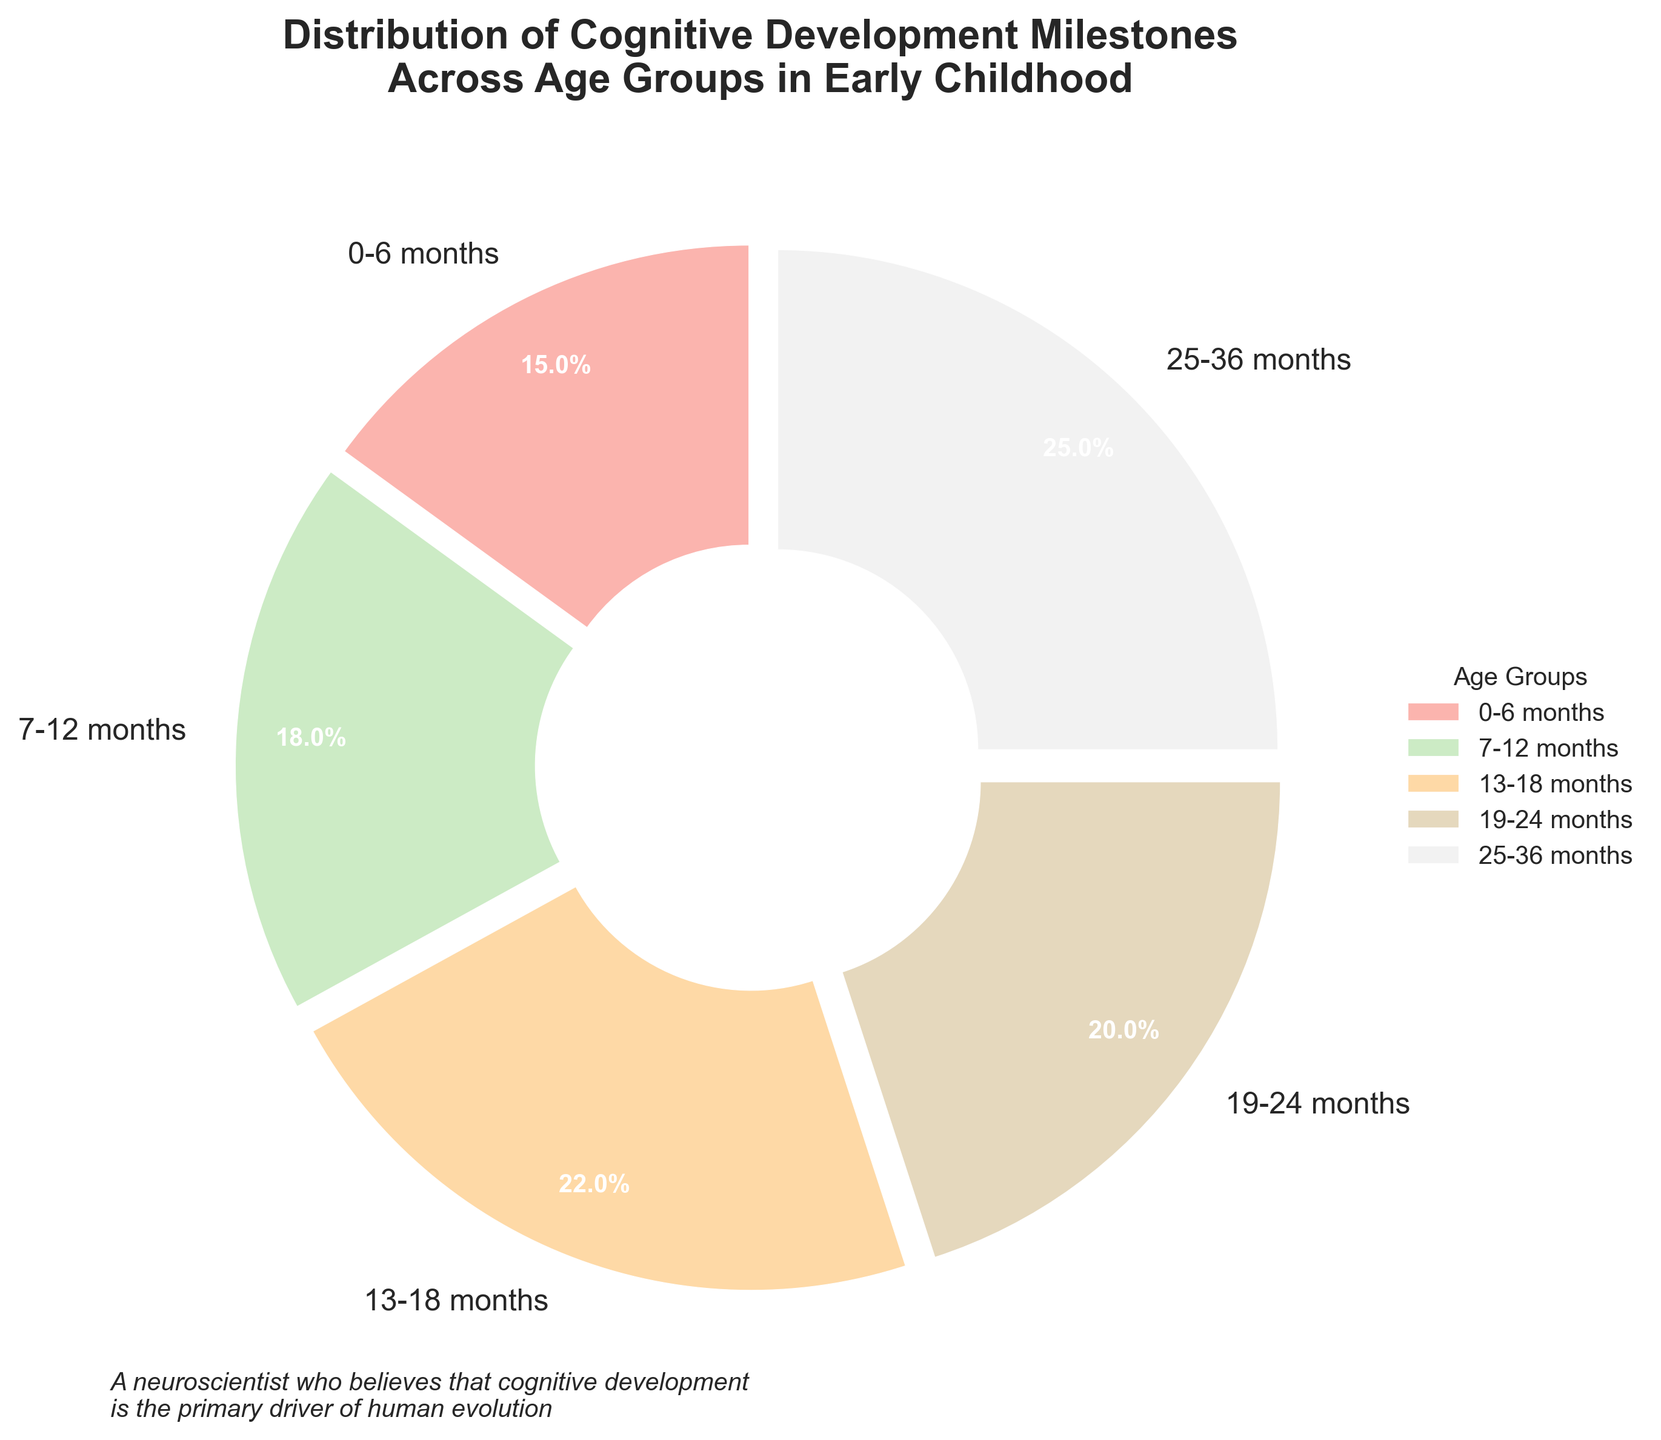What age group has the highest percentage of cognitive development milestones? By looking at the pie chart, the segment corresponding to the age group 25-36 months is the largest, representing the highest percentage of cognitive development milestones.
Answer: 25-36 months Which age group has a lower percentage of cognitive development milestones: 0-6 months or 7-12 months? Comparing the pie chart segments for the age groups 0-6 months and 7-12 months, the 0-6 months segment is smaller, indicating a lower percentage.
Answer: 0-6 months What is the combined percentage of cognitive milestones for the age groups 13-18 months and 19-24 months? The pie chart shows 22% for the 13-18 months age group and 20% for the 19-24 months age group. Adding these percentages gives 22 + 20 = 42%.
Answer: 42% How much larger is the percentage of the 25-36 months age group compared to the 0-6 months age group? The pie chart shows 25% for 25-36 months and 15% for 0-6 months. The difference between them is 25 - 15 = 10%.
Answer: 10% Which two age groups have the most similar percentages of cognitive development milestones? By visually comparing the segments on the pie chart, the age groups 19-24 months and 13-18 months are the most similar, with percentages of 20% and 22%, respectively.
Answer: 19-24 months and 13-18 months What percentage of cognitive development milestones occur before the age of 1 year? The pie chart shows 15% for 0-6 months and 18% for 7-12 months. Adding these gives 15 + 18 = 33%.
Answer: 33% How many age groups have a percentage of cognitive development milestones above 20%? Examining the pie chart, the age groups 13-18 months (22%) and 25-36 months (25%) have percentages above 20%. Thus, there are 2 such age groups.
Answer: 2 What age group contributes the least to the distribution of cognitive development milestones? The pie chart indicates that the smallest segment, corresponding to the age group 0-6 months, represents the least contribution with a percentage of 15%.
Answer: 0-6 months What is the total percentage of cognitive development milestones happening after 1 year of age? The pie chart sections for age groups after 1 year are 13-18 months (22%), 19-24 months (20%), and 25-36 months (25%). Summing these gives 22 + 20 + 25 = 67%.
Answer: 67% 